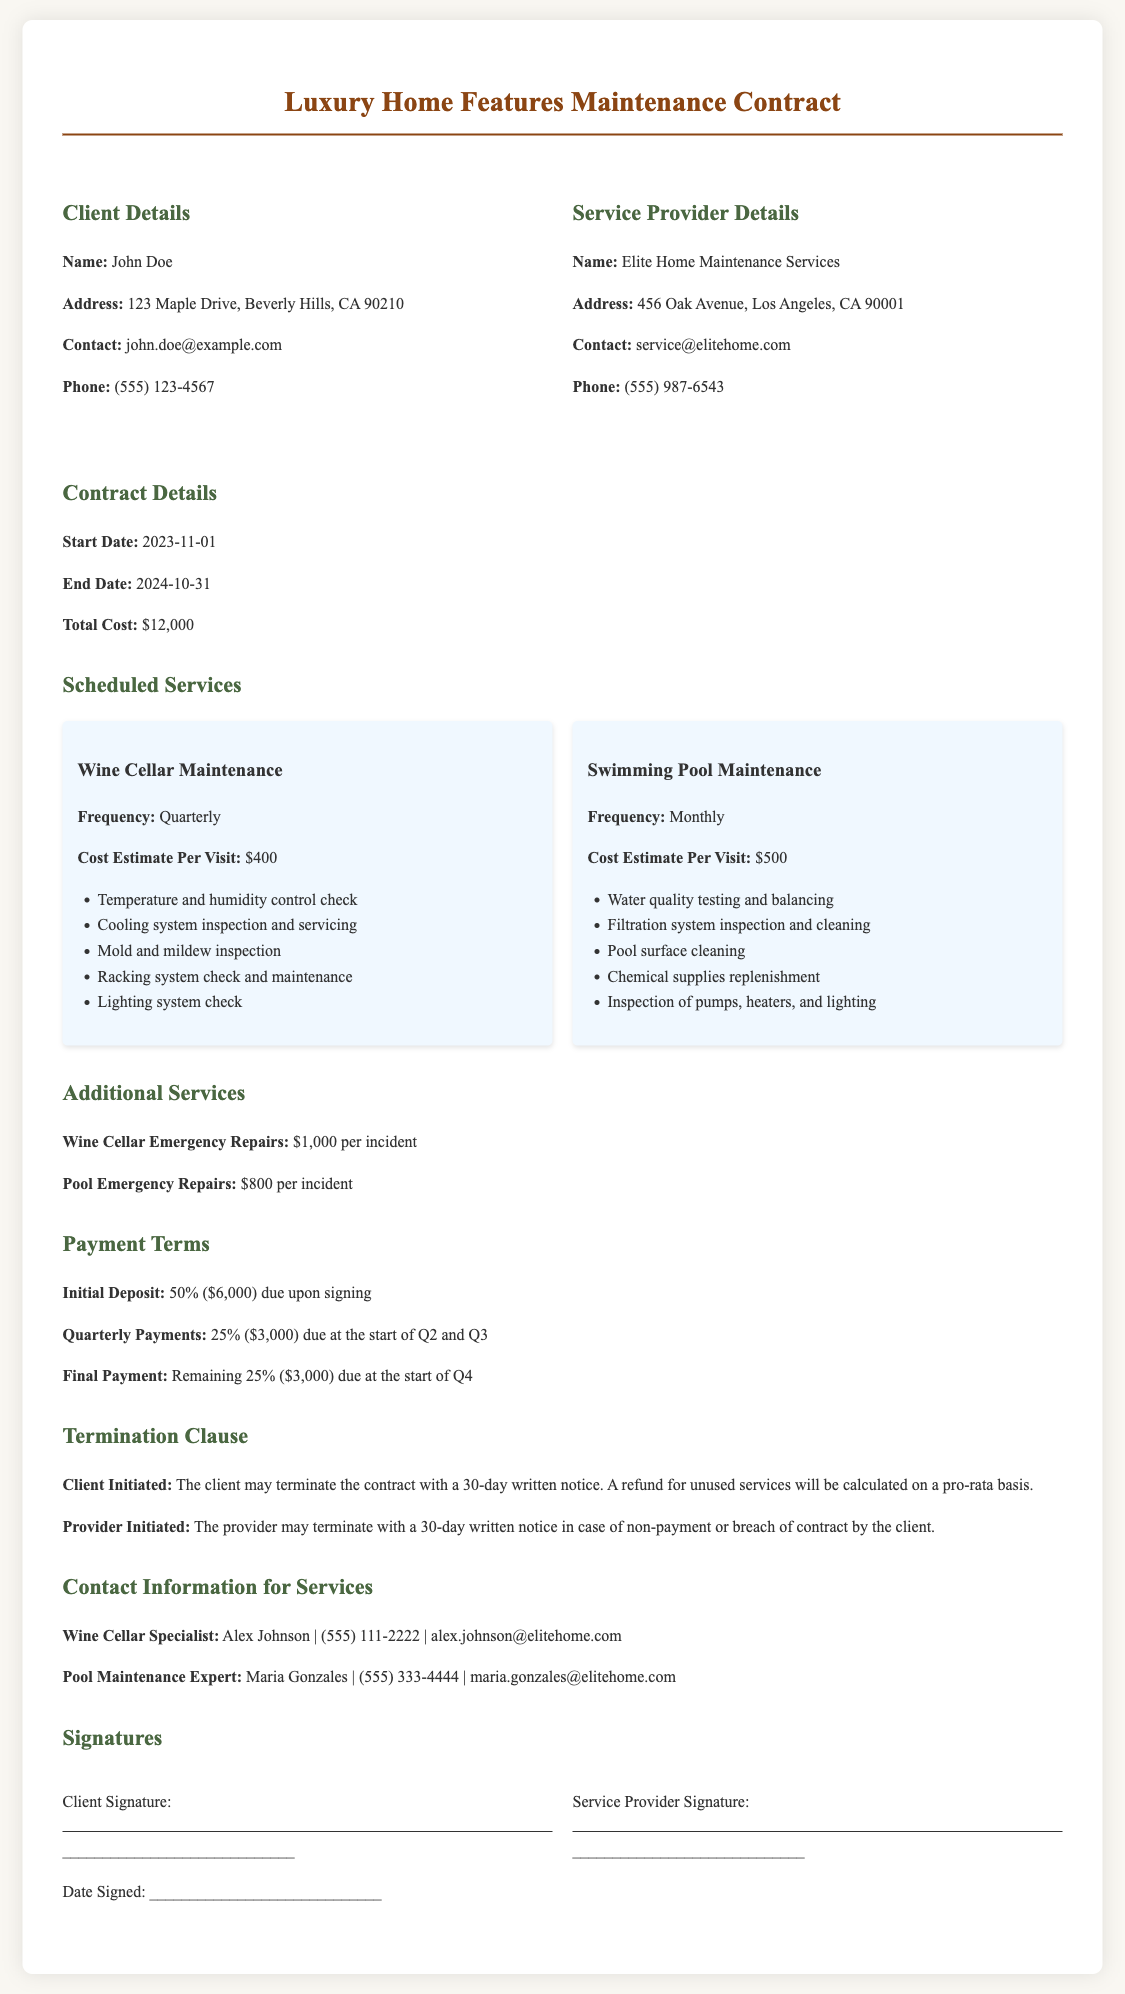What is the client's name? The document provides the name of the client in the Client Details section, which is John Doe.
Answer: John Doe What is the total cost of the contract? The total cost is specified in the Contract Details section as $12,000.
Answer: $12,000 How frequently is the swimming pool maintenance scheduled? The frequency of swimming pool maintenance is stated under Scheduled Services, which is monthly.
Answer: Monthly What is the cost estimate per visit for wine cellar maintenance? The document specifies the cost estimate per visit for wine cellar maintenance, which is $400.
Answer: $400 What is the initial deposit percentage due upon signing? The Payment Terms section indicates that the initial deposit is 50% due upon signing.
Answer: 50% How many days notice is required for client-initiated termination of the contract? The Termination Clause states that a 30-day written notice is required for client-initiated termination.
Answer: 30-day What is the contact email for the wine cellar specialist? The Contact Information for Services section lists the email of the wine cellar specialist, which is alex.johnson@elitehome.com.
Answer: alex.johnson@elitehome.com What additional service cost is mentioned for wine cellar emergency repairs? The document mentions the cost for wine cellar emergency repairs as $1,000 per incident in Additional Services.
Answer: $1,000 Which section contains the client and service provider details? The Client Details and Service Provider Details are found in the grid under both respective headings in the document.
Answer: Client Details and Service Provider Details 